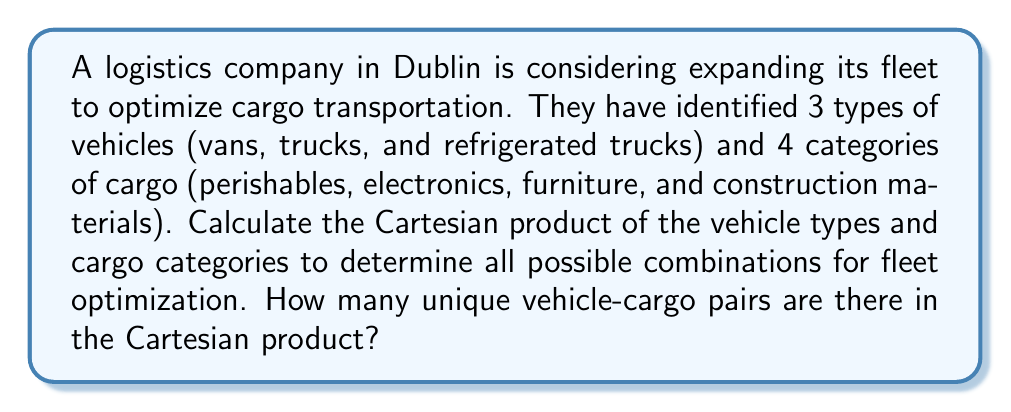Can you solve this math problem? To solve this problem, we need to understand the concept of Cartesian product and how to calculate it.

1. Let's define our sets:
   $V$ = {vans, trucks, refrigerated trucks}
   $C$ = {perishables, electronics, furniture, construction materials}

2. The Cartesian product of sets $V$ and $C$ is denoted as $V \times C$. It consists of all ordered pairs $(v, c)$ where $v \in V$ and $c \in C$.

3. To calculate the number of elements in the Cartesian product, we use the multiplication principle:
   $|V \times C| = |V| \times |C|$

   Where $|V|$ is the number of elements in set $V$, and $|C|$ is the number of elements in set $C$.

4. In this case:
   $|V| = 3$ (vans, trucks, refrigerated trucks)
   $|C| = 4$ (perishables, electronics, furniture, construction materials)

5. Therefore, the number of unique vehicle-cargo pairs is:
   $|V \times C| = 3 \times 4 = 12$

This means there are 12 possible combinations of vehicle types and cargo categories, which the logistics company can consider for optimizing their fleet operations.
Answer: The Cartesian product $V \times C$ contains 12 unique vehicle-cargo pairs. 